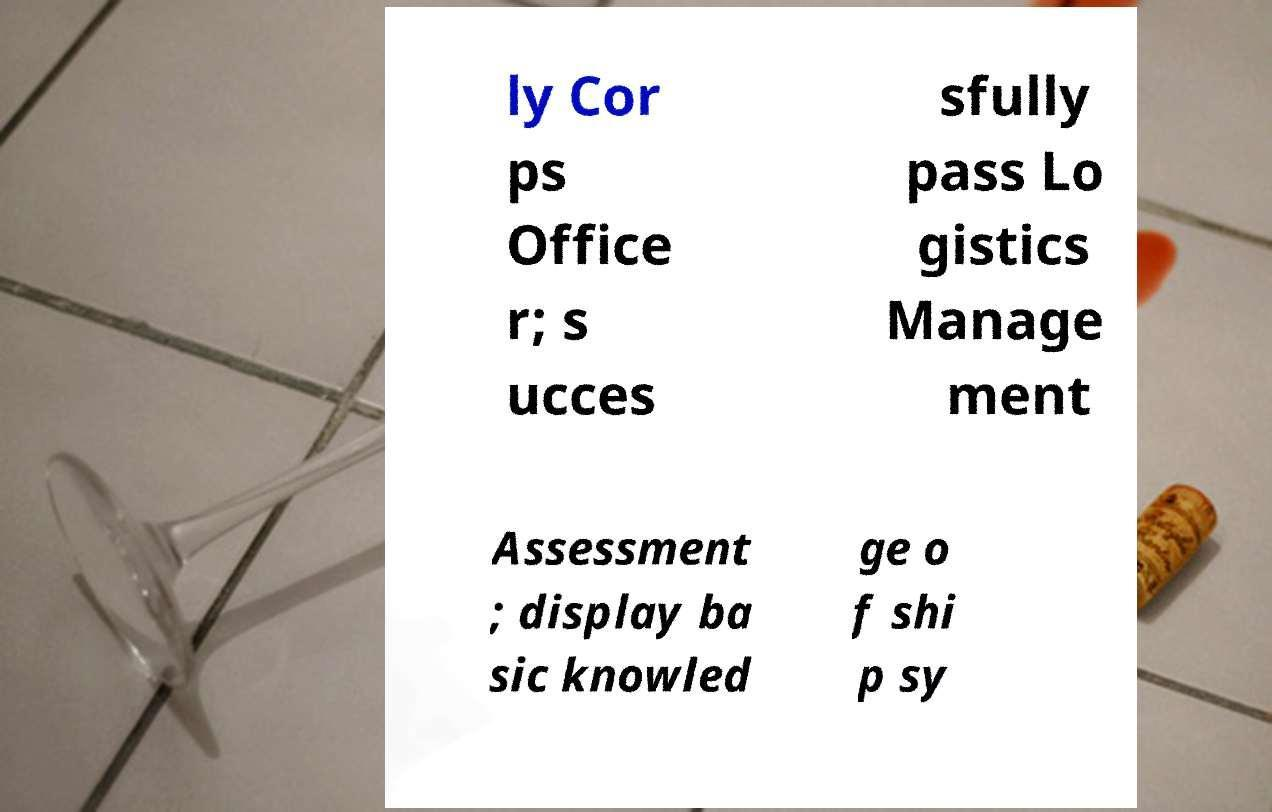What messages or text are displayed in this image? I need them in a readable, typed format. ly Cor ps Office r; s ucces sfully pass Lo gistics Manage ment Assessment ; display ba sic knowled ge o f shi p sy 